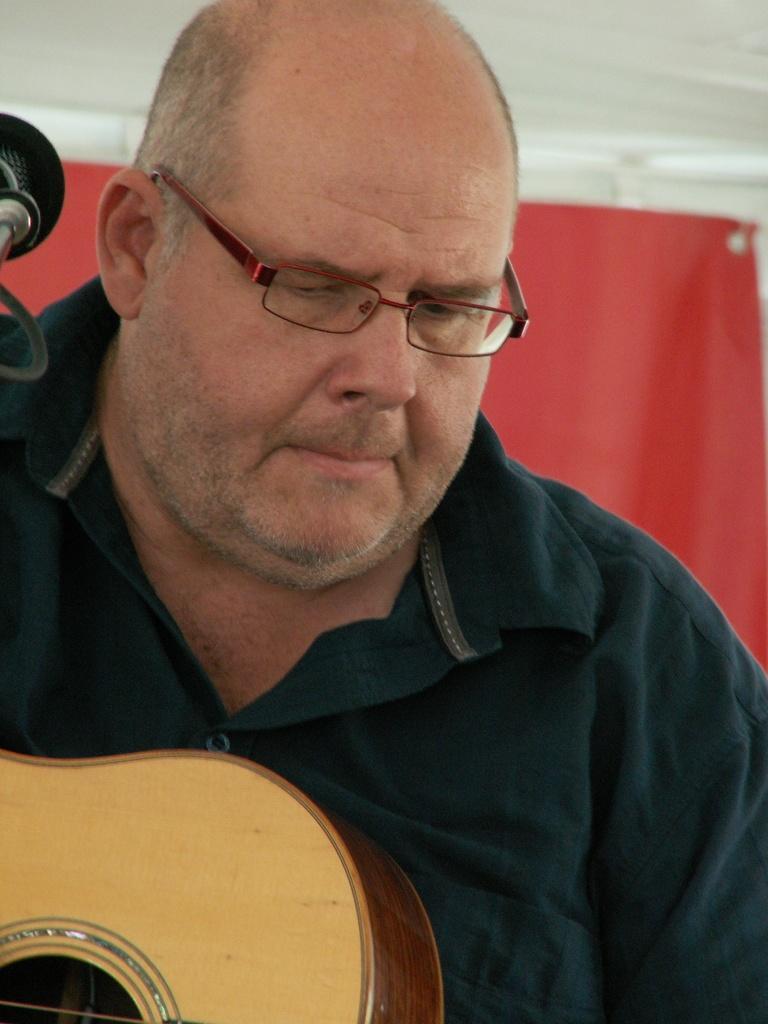What is the main subject of the image? There is a man in the image. What is the man holding in the image? The man is holding a musical instrument. What other object is present in the image that might be related to the man's activity? There is a microphone in the image. What type of hammer is the man using to play the musical instrument in the image? There is no hammer present in the image, and the man is not using a hammer to play the musical instrument. 